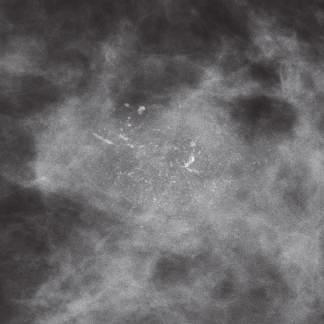what is mammographic detection of calcifications associated with?
Answer the question using a single word or phrase. Dcis 